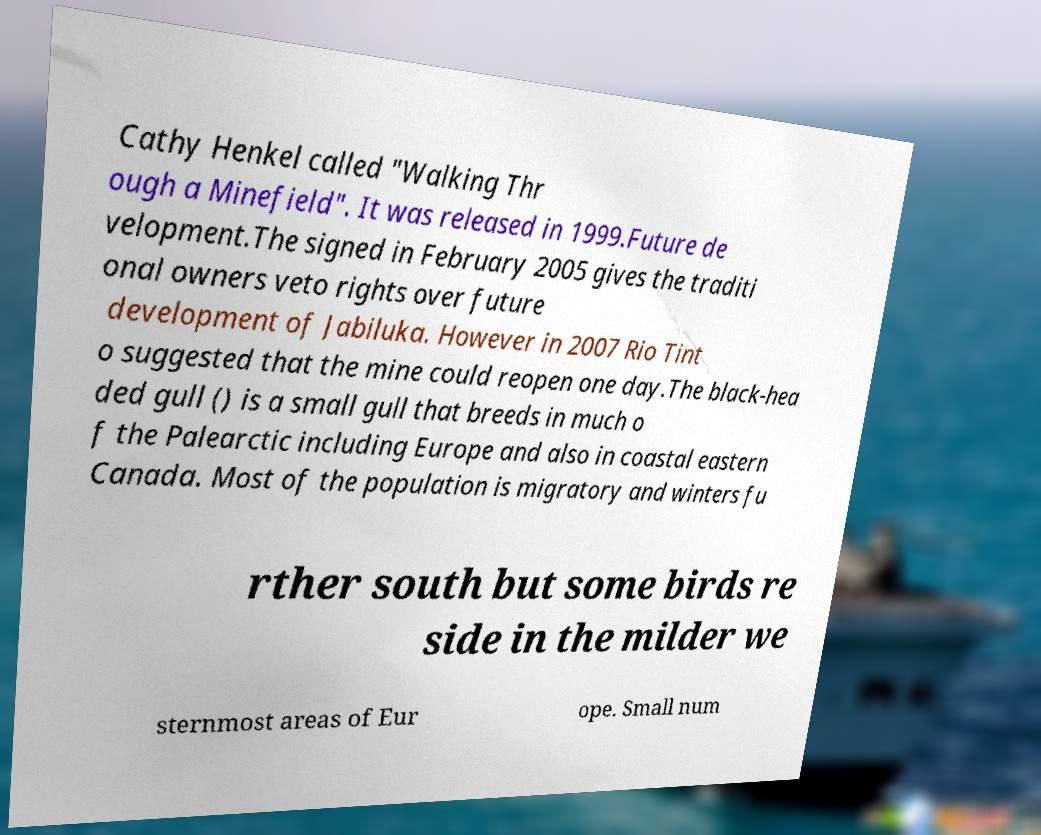There's text embedded in this image that I need extracted. Can you transcribe it verbatim? Cathy Henkel called "Walking Thr ough a Minefield". It was released in 1999.Future de velopment.The signed in February 2005 gives the traditi onal owners veto rights over future development of Jabiluka. However in 2007 Rio Tint o suggested that the mine could reopen one day.The black-hea ded gull () is a small gull that breeds in much o f the Palearctic including Europe and also in coastal eastern Canada. Most of the population is migratory and winters fu rther south but some birds re side in the milder we sternmost areas of Eur ope. Small num 